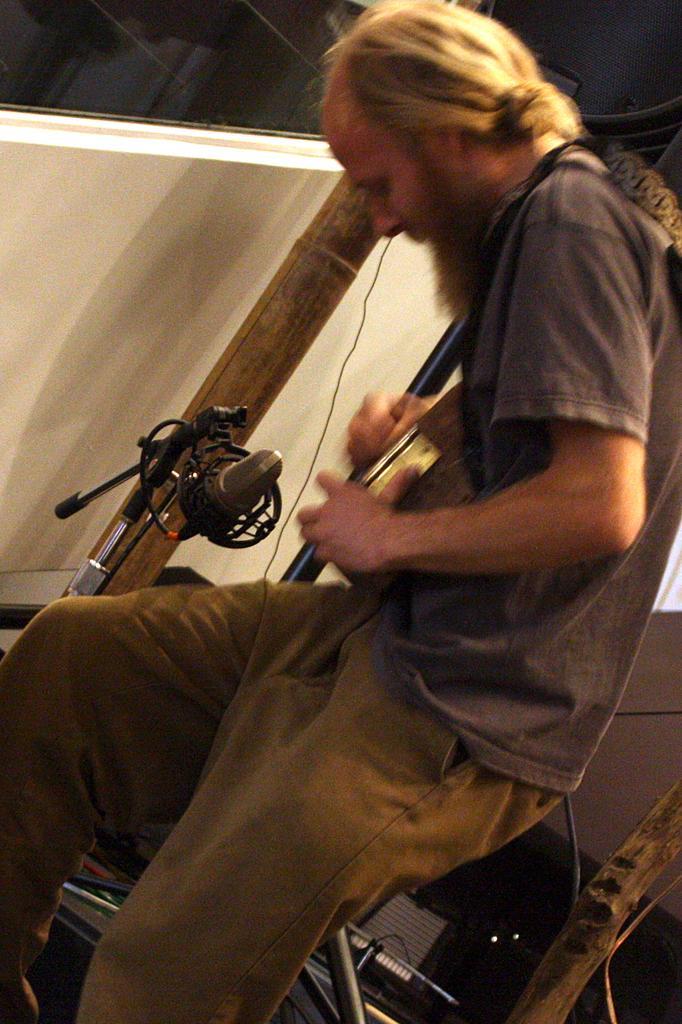How would you summarize this image in a sentence or two? In the picture I can see a person standing and holding an object in his hands and there are some other objects in the background. 